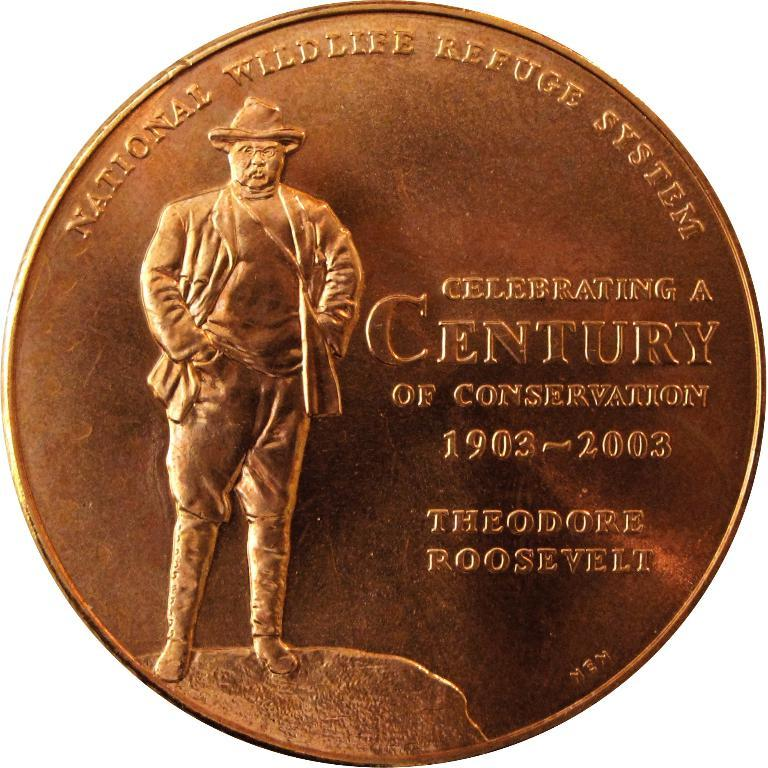<image>
Relay a brief, clear account of the picture shown. A copper memorabilia coin for President Theodore Roosevelt. 